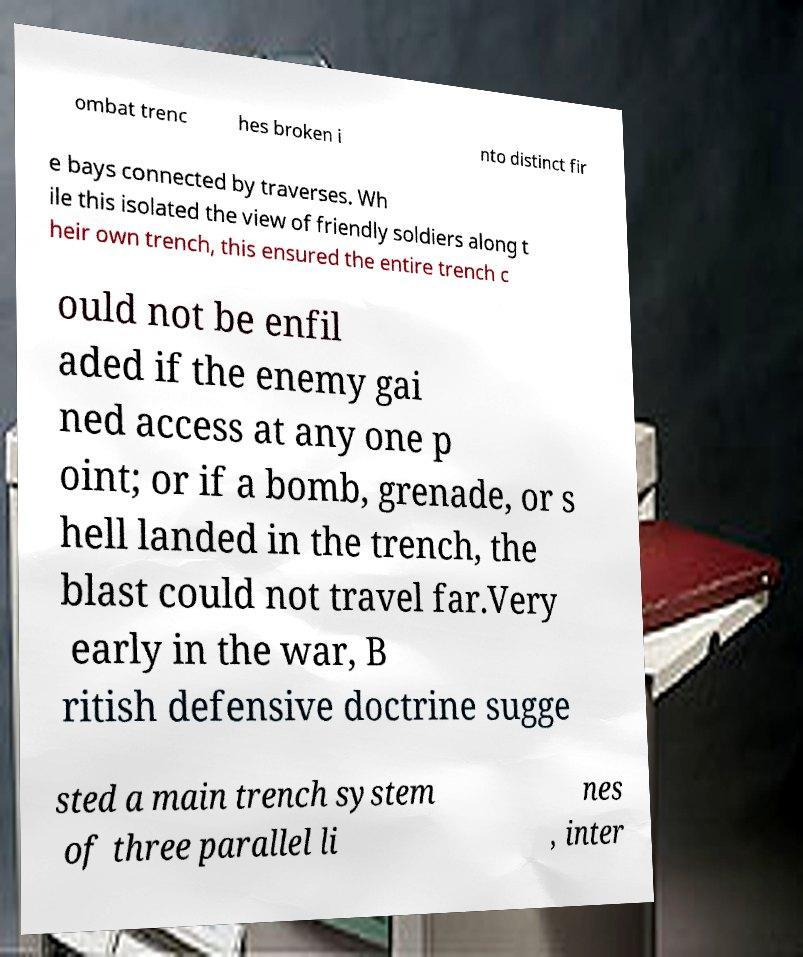Can you accurately transcribe the text from the provided image for me? ombat trenc hes broken i nto distinct fir e bays connected by traverses. Wh ile this isolated the view of friendly soldiers along t heir own trench, this ensured the entire trench c ould not be enfil aded if the enemy gai ned access at any one p oint; or if a bomb, grenade, or s hell landed in the trench, the blast could not travel far.Very early in the war, B ritish defensive doctrine sugge sted a main trench system of three parallel li nes , inter 